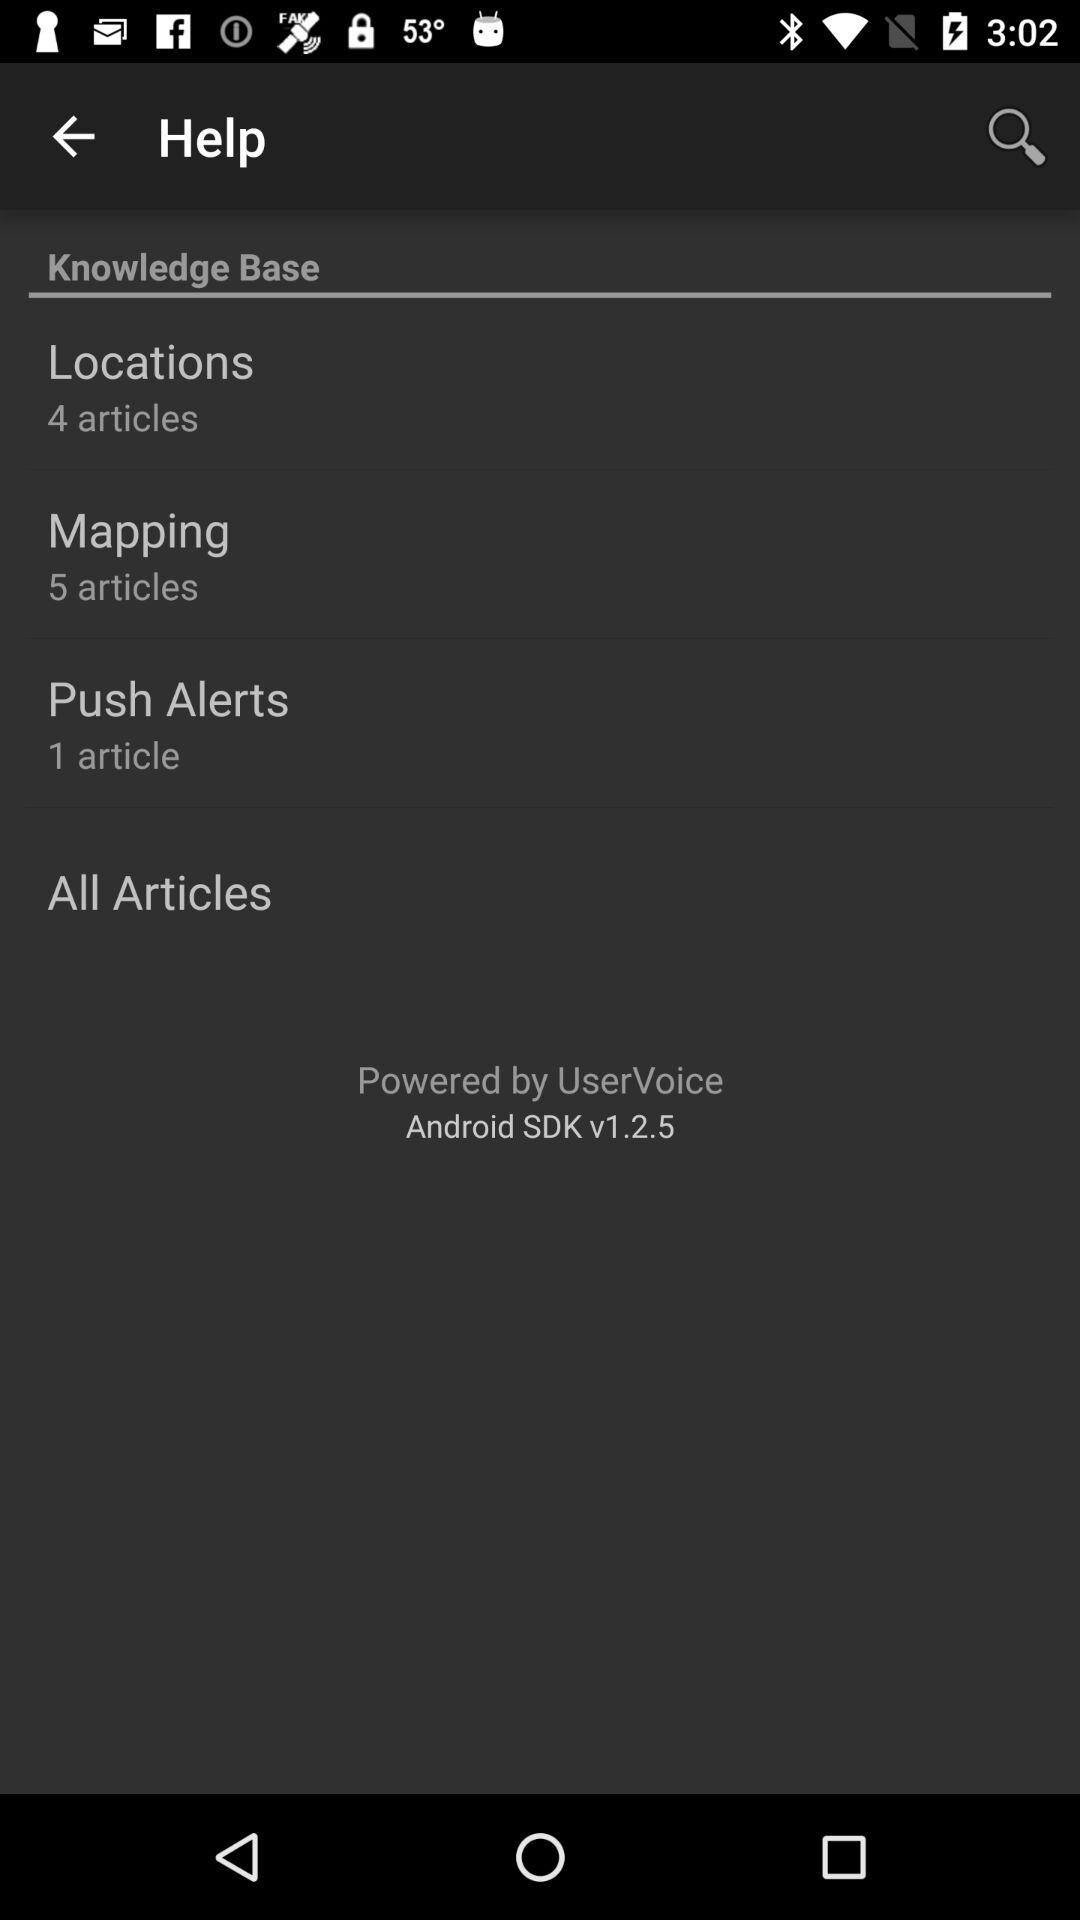How many articles are there in the "Push Alerts"? There is 1 article in the "Push Alerts". 